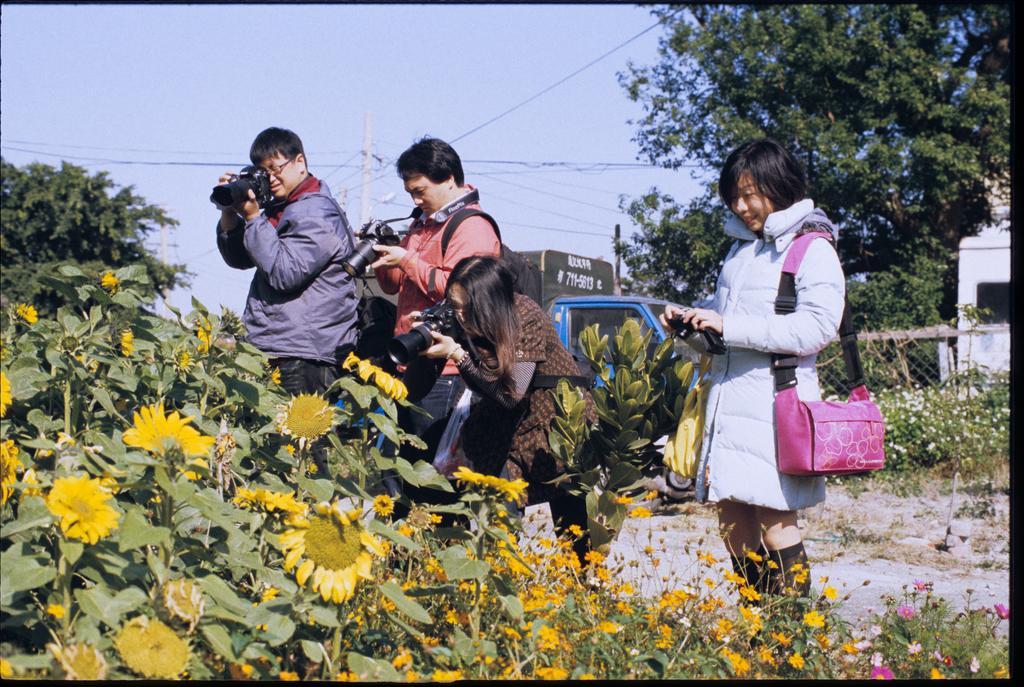In one or two sentences, can you explain what this image depicts? In the image there are four persons standing and clicking pictures of sunflower plants on the left side, in the back there is truck on the road and behind it there are trees, in the middle there is an electric pole and above its sky. 